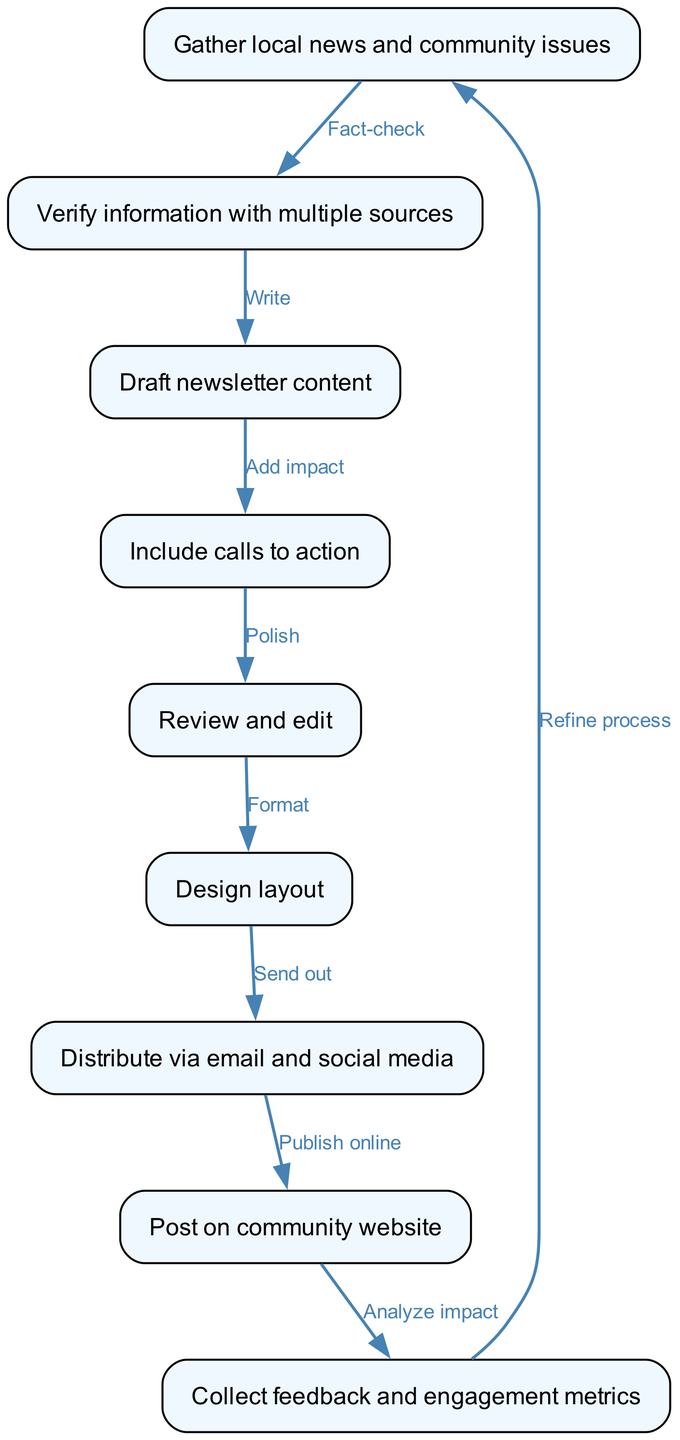What is the first step in the workflow? The first step in the workflow is to "Gather local news and community issues," which is represented by node 1.
Answer: Gather local news and community issues How many nodes are in the diagram? By counting each unique item described in the nodes section, we find there are nine nodes total.
Answer: 9 Which two nodes are connected by the edge labeled "Write"? The edge labeled "Write" connects node 2, "Verify information with multiple sources," to node 3, "Draft newsletter content."
Answer: Verify information with multiple sources, Draft newsletter content What is the last step before collecting feedback? The last step before collecting feedback is "Post on community website," which is represented by node 8.
Answer: Post on community website What happens after distributing the newsletter? After distributing the newsletter, the next action is to "Post on community website," as shown in the diagram.
Answer: Post on community website Which step includes adding impact? The step that includes adding impact is represented by node 4, "Include calls to action."
Answer: Include calls to action How is feedback used in the workflow? Feedback is collected and analyzed to "Refine process," creating a loop back to the first step, ensuring continuous improvement.
Answer: Refine process What is the relationship between "Review and edit" and "Design layout"? The relationship is that "Review and edit" must occur before "Design layout," indicated by the edge directed from node 5 to node 6, showing a sequential process.
Answer: Review and edit precedes Design layout 